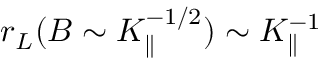<formula> <loc_0><loc_0><loc_500><loc_500>r _ { L } ( B \sim K _ { \| } ^ { - 1 / 2 } ) \sim K _ { \| } ^ { - 1 }</formula> 